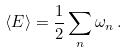Convert formula to latex. <formula><loc_0><loc_0><loc_500><loc_500>\langle E \rangle = { \frac { 1 } { 2 } } \sum _ { n } \omega _ { n } \, .</formula> 